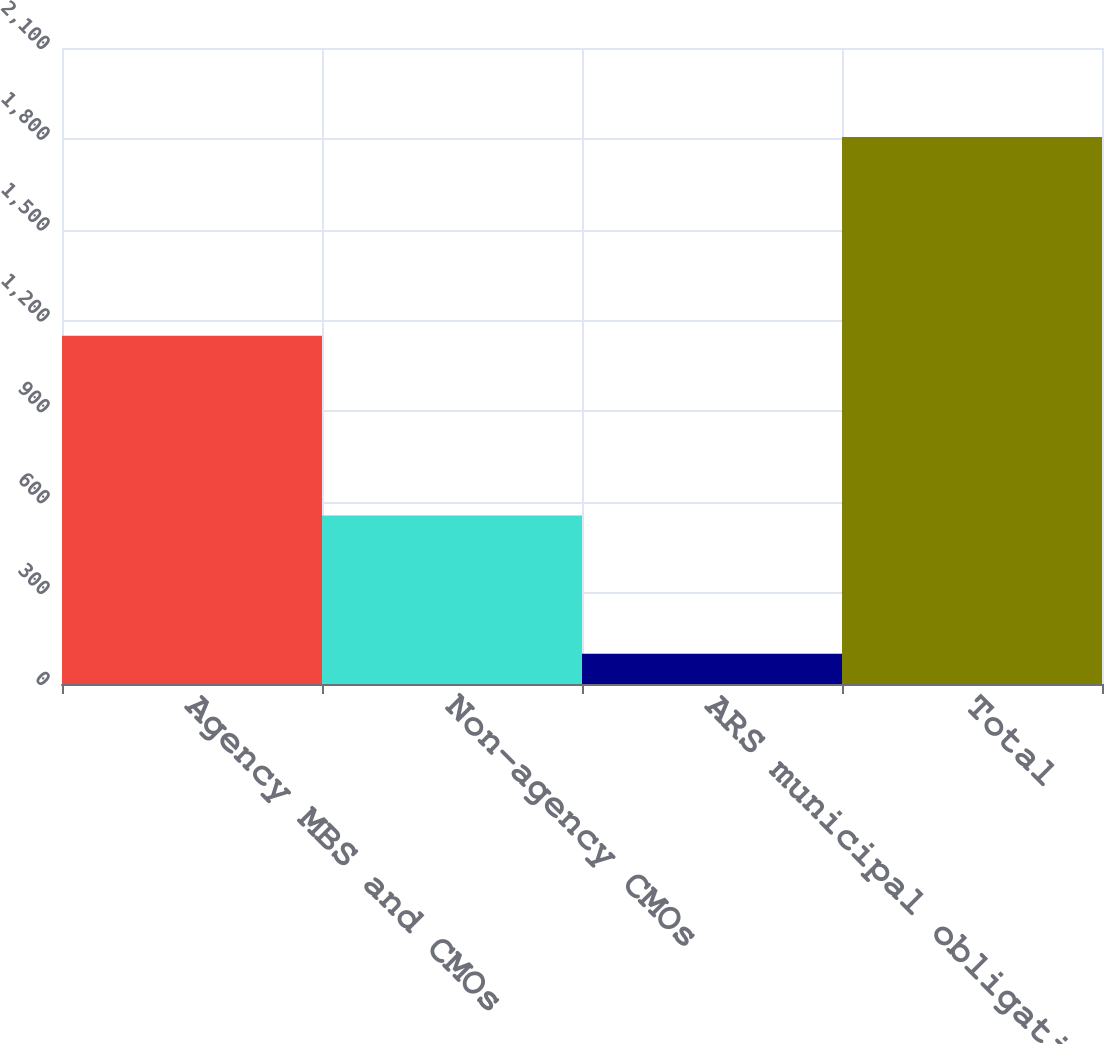<chart> <loc_0><loc_0><loc_500><loc_500><bar_chart><fcel>Agency MBS and CMOs<fcel>Non-agency CMOs<fcel>ARS municipal obligations<fcel>Total<nl><fcel>1150<fcel>556<fcel>100<fcel>1806<nl></chart> 